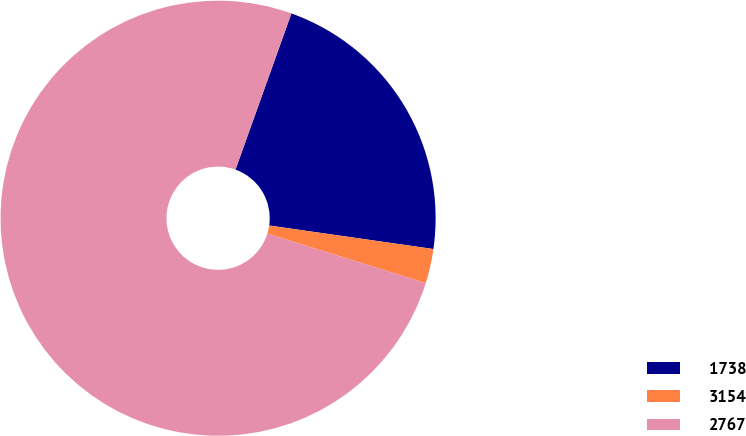Convert chart to OTSL. <chart><loc_0><loc_0><loc_500><loc_500><pie_chart><fcel>1738<fcel>3154<fcel>2767<nl><fcel>21.79%<fcel>2.56%<fcel>75.64%<nl></chart> 